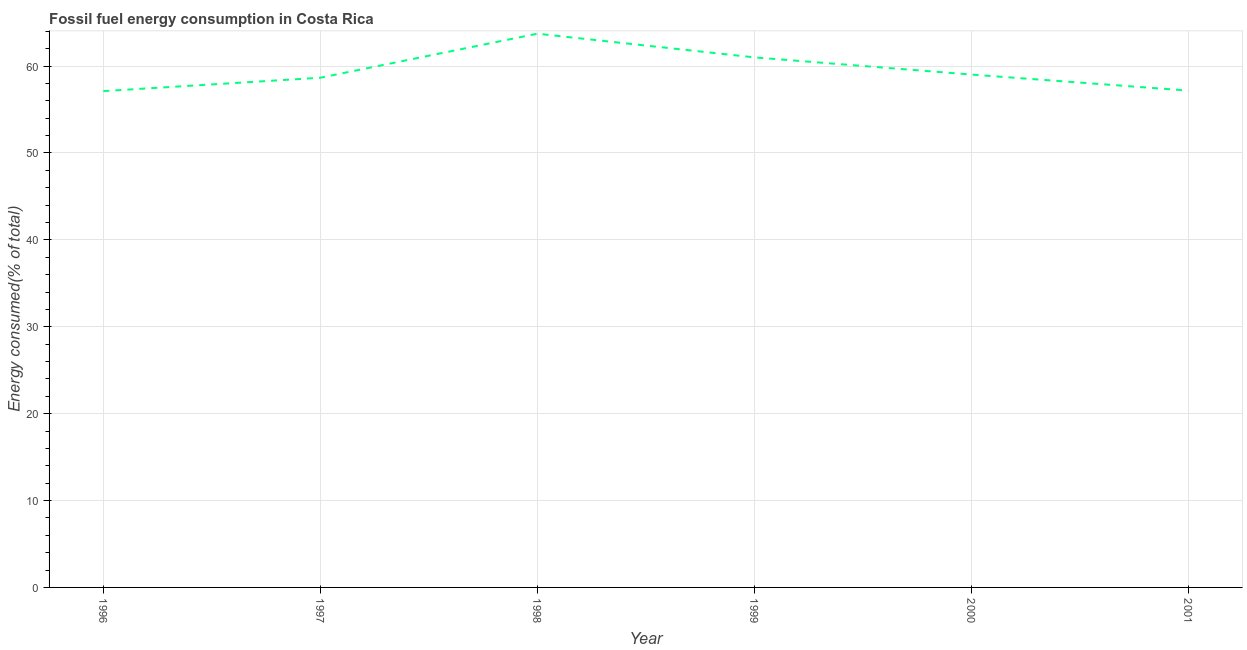What is the fossil fuel energy consumption in 1997?
Your response must be concise. 58.66. Across all years, what is the maximum fossil fuel energy consumption?
Provide a short and direct response. 63.73. Across all years, what is the minimum fossil fuel energy consumption?
Give a very brief answer. 57.12. In which year was the fossil fuel energy consumption minimum?
Provide a short and direct response. 1996. What is the sum of the fossil fuel energy consumption?
Offer a very short reply. 356.72. What is the difference between the fossil fuel energy consumption in 1999 and 2000?
Give a very brief answer. 1.98. What is the average fossil fuel energy consumption per year?
Your answer should be compact. 59.45. What is the median fossil fuel energy consumption?
Provide a succinct answer. 58.84. In how many years, is the fossil fuel energy consumption greater than 12 %?
Give a very brief answer. 6. What is the ratio of the fossil fuel energy consumption in 1998 to that in 2000?
Your response must be concise. 1.08. Is the fossil fuel energy consumption in 1997 less than that in 2001?
Make the answer very short. No. What is the difference between the highest and the second highest fossil fuel energy consumption?
Provide a short and direct response. 2.73. Is the sum of the fossil fuel energy consumption in 1996 and 2000 greater than the maximum fossil fuel energy consumption across all years?
Offer a terse response. Yes. What is the difference between the highest and the lowest fossil fuel energy consumption?
Keep it short and to the point. 6.61. In how many years, is the fossil fuel energy consumption greater than the average fossil fuel energy consumption taken over all years?
Your answer should be very brief. 2. How many lines are there?
Make the answer very short. 1. How many years are there in the graph?
Provide a short and direct response. 6. Does the graph contain any zero values?
Provide a short and direct response. No. Does the graph contain grids?
Give a very brief answer. Yes. What is the title of the graph?
Ensure brevity in your answer.  Fossil fuel energy consumption in Costa Rica. What is the label or title of the X-axis?
Ensure brevity in your answer.  Year. What is the label or title of the Y-axis?
Offer a very short reply. Energy consumed(% of total). What is the Energy consumed(% of total) in 1996?
Offer a terse response. 57.12. What is the Energy consumed(% of total) in 1997?
Provide a succinct answer. 58.66. What is the Energy consumed(% of total) of 1998?
Your answer should be compact. 63.73. What is the Energy consumed(% of total) of 1999?
Keep it short and to the point. 61. What is the Energy consumed(% of total) of 2000?
Your response must be concise. 59.03. What is the Energy consumed(% of total) in 2001?
Your response must be concise. 57.18. What is the difference between the Energy consumed(% of total) in 1996 and 1997?
Your response must be concise. -1.54. What is the difference between the Energy consumed(% of total) in 1996 and 1998?
Your response must be concise. -6.61. What is the difference between the Energy consumed(% of total) in 1996 and 1999?
Offer a terse response. -3.88. What is the difference between the Energy consumed(% of total) in 1996 and 2000?
Offer a very short reply. -1.91. What is the difference between the Energy consumed(% of total) in 1996 and 2001?
Your answer should be very brief. -0.06. What is the difference between the Energy consumed(% of total) in 1997 and 1998?
Provide a short and direct response. -5.07. What is the difference between the Energy consumed(% of total) in 1997 and 1999?
Provide a short and direct response. -2.34. What is the difference between the Energy consumed(% of total) in 1997 and 2000?
Offer a very short reply. -0.37. What is the difference between the Energy consumed(% of total) in 1997 and 2001?
Provide a short and direct response. 1.48. What is the difference between the Energy consumed(% of total) in 1998 and 1999?
Your answer should be compact. 2.73. What is the difference between the Energy consumed(% of total) in 1998 and 2000?
Your response must be concise. 4.7. What is the difference between the Energy consumed(% of total) in 1998 and 2001?
Keep it short and to the point. 6.55. What is the difference between the Energy consumed(% of total) in 1999 and 2000?
Offer a very short reply. 1.98. What is the difference between the Energy consumed(% of total) in 1999 and 2001?
Offer a very short reply. 3.82. What is the difference between the Energy consumed(% of total) in 2000 and 2001?
Offer a terse response. 1.85. What is the ratio of the Energy consumed(% of total) in 1996 to that in 1998?
Your response must be concise. 0.9. What is the ratio of the Energy consumed(% of total) in 1996 to that in 1999?
Ensure brevity in your answer.  0.94. What is the ratio of the Energy consumed(% of total) in 1996 to that in 2000?
Your answer should be compact. 0.97. What is the ratio of the Energy consumed(% of total) in 1996 to that in 2001?
Give a very brief answer. 1. What is the ratio of the Energy consumed(% of total) in 1997 to that in 2001?
Provide a short and direct response. 1.03. What is the ratio of the Energy consumed(% of total) in 1998 to that in 1999?
Keep it short and to the point. 1.04. What is the ratio of the Energy consumed(% of total) in 1998 to that in 2001?
Provide a short and direct response. 1.11. What is the ratio of the Energy consumed(% of total) in 1999 to that in 2000?
Make the answer very short. 1.03. What is the ratio of the Energy consumed(% of total) in 1999 to that in 2001?
Your answer should be very brief. 1.07. What is the ratio of the Energy consumed(% of total) in 2000 to that in 2001?
Your answer should be compact. 1.03. 